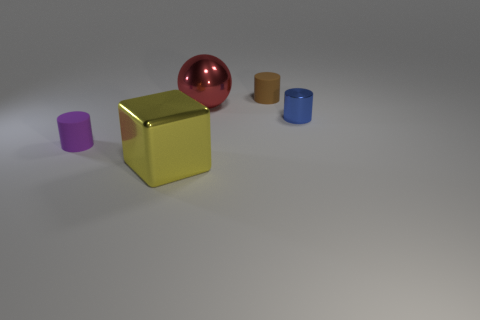Can you describe how light interacts with the different materials shown in the image? Certainly. The metal sphere and the yellow cube both exhibit reflective surfaces, indicative of metallic materials that reflect light and create highlights. The matte purple cube diffuses light uniformly, which indicates a non-reflective surface, possibly a kind of plastic or painted wood. Lastly, the rubber cylinders have a slight sheen, reflecting some light but not as much as the metals, suggesting a semi-gloss rubber material. 